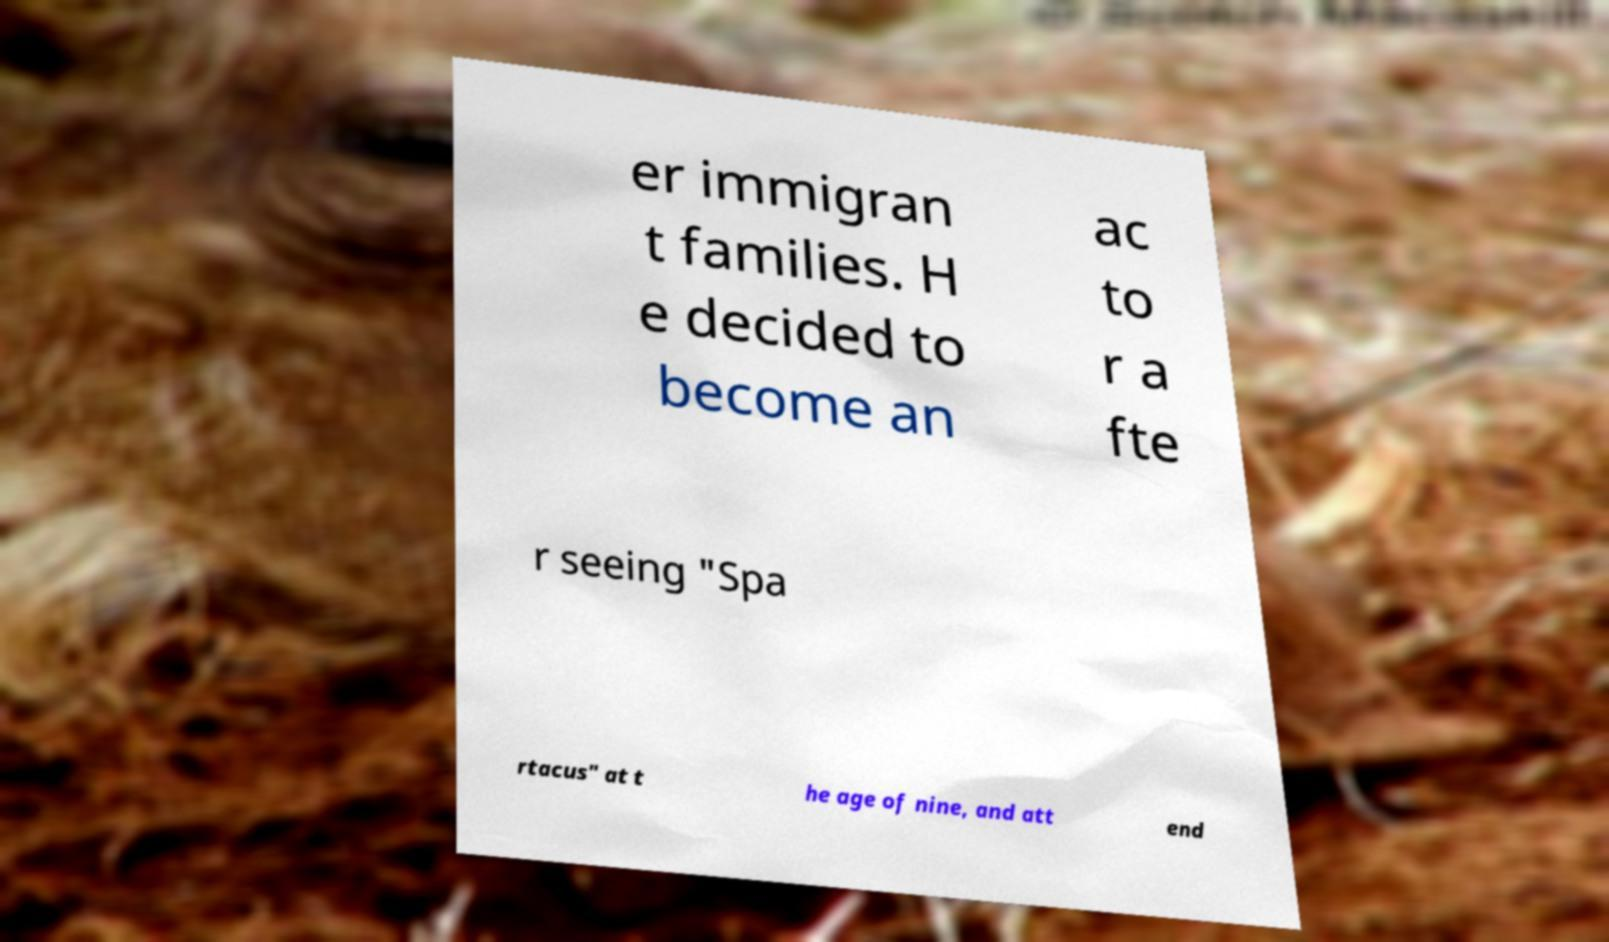Could you extract and type out the text from this image? er immigran t families. H e decided to become an ac to r a fte r seeing "Spa rtacus" at t he age of nine, and att end 